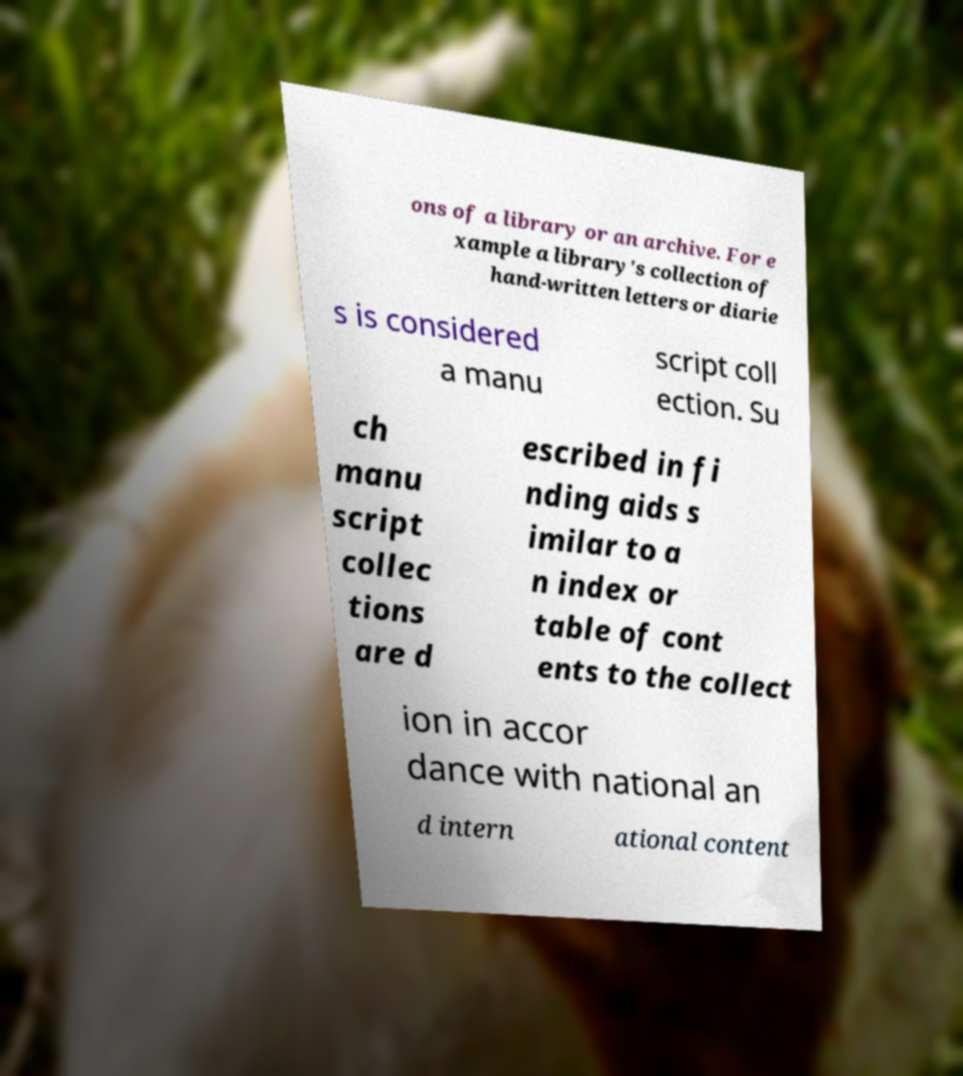Can you accurately transcribe the text from the provided image for me? ons of a library or an archive. For e xample a library's collection of hand-written letters or diarie s is considered a manu script coll ection. Su ch manu script collec tions are d escribed in fi nding aids s imilar to a n index or table of cont ents to the collect ion in accor dance with national an d intern ational content 